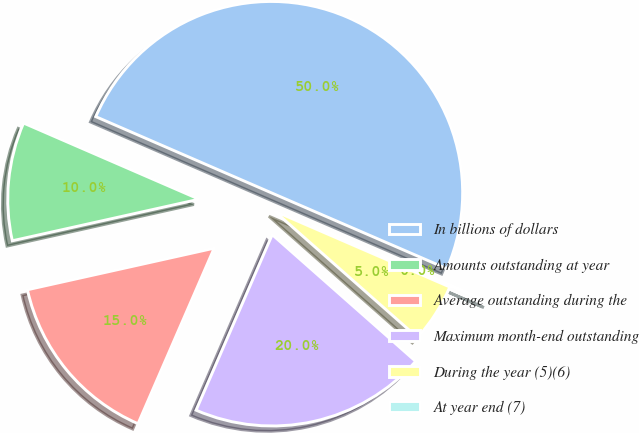Convert chart. <chart><loc_0><loc_0><loc_500><loc_500><pie_chart><fcel>In billions of dollars<fcel>Amounts outstanding at year<fcel>Average outstanding during the<fcel>Maximum month-end outstanding<fcel>During the year (5)(6)<fcel>At year end (7)<nl><fcel>49.98%<fcel>10.0%<fcel>15.0%<fcel>20.0%<fcel>5.01%<fcel>0.01%<nl></chart> 